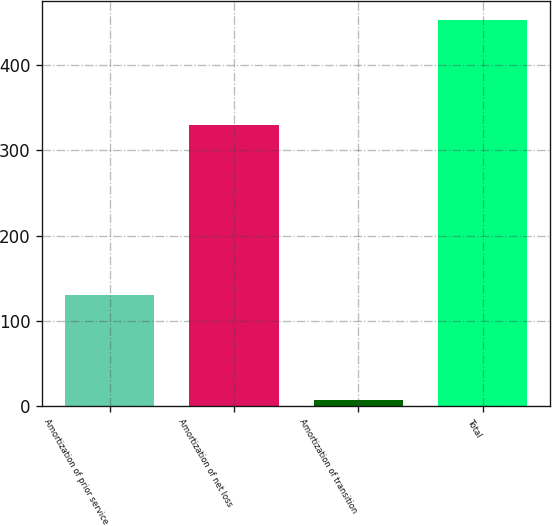Convert chart. <chart><loc_0><loc_0><loc_500><loc_500><bar_chart><fcel>Amortization of prior service<fcel>Amortization of net loss<fcel>Amortization of transition<fcel>Total<nl><fcel>130<fcel>330<fcel>7<fcel>453<nl></chart> 